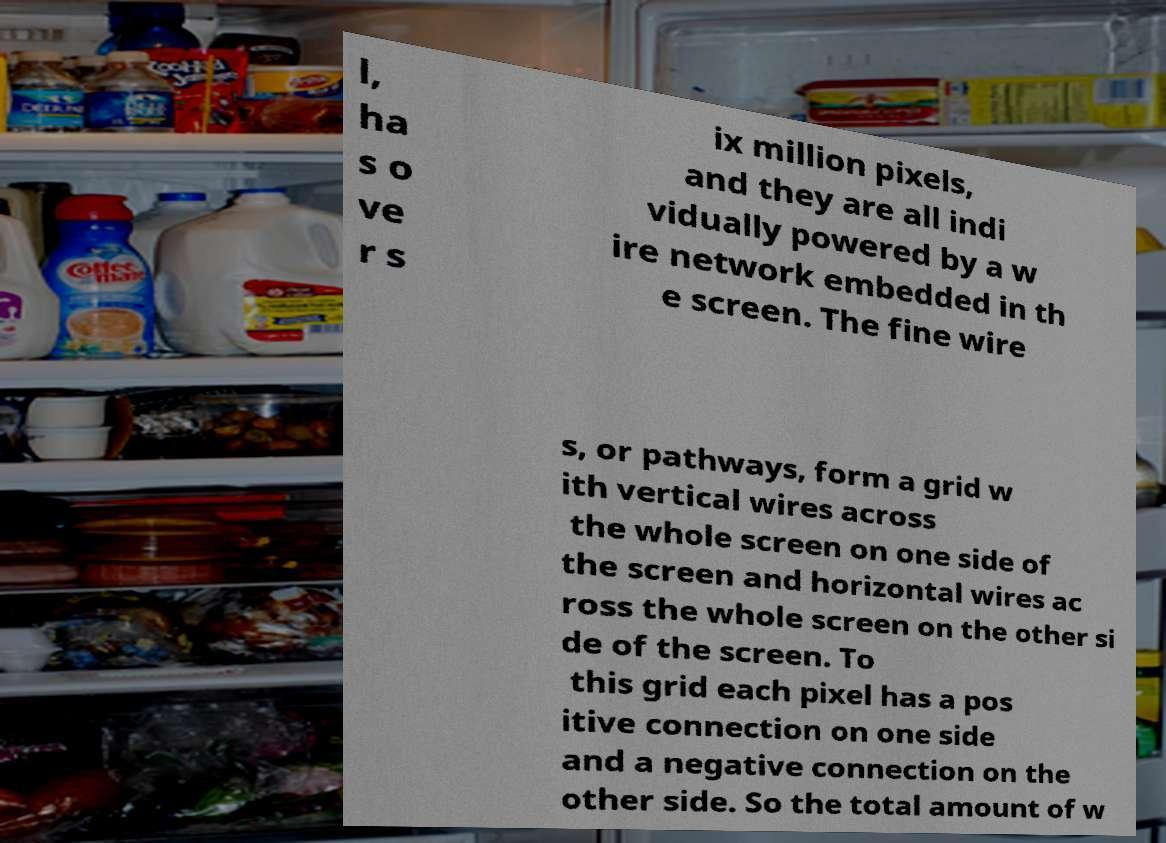Please read and relay the text visible in this image. What does it say? l, ha s o ve r s ix million pixels, and they are all indi vidually powered by a w ire network embedded in th e screen. The fine wire s, or pathways, form a grid w ith vertical wires across the whole screen on one side of the screen and horizontal wires ac ross the whole screen on the other si de of the screen. To this grid each pixel has a pos itive connection on one side and a negative connection on the other side. So the total amount of w 